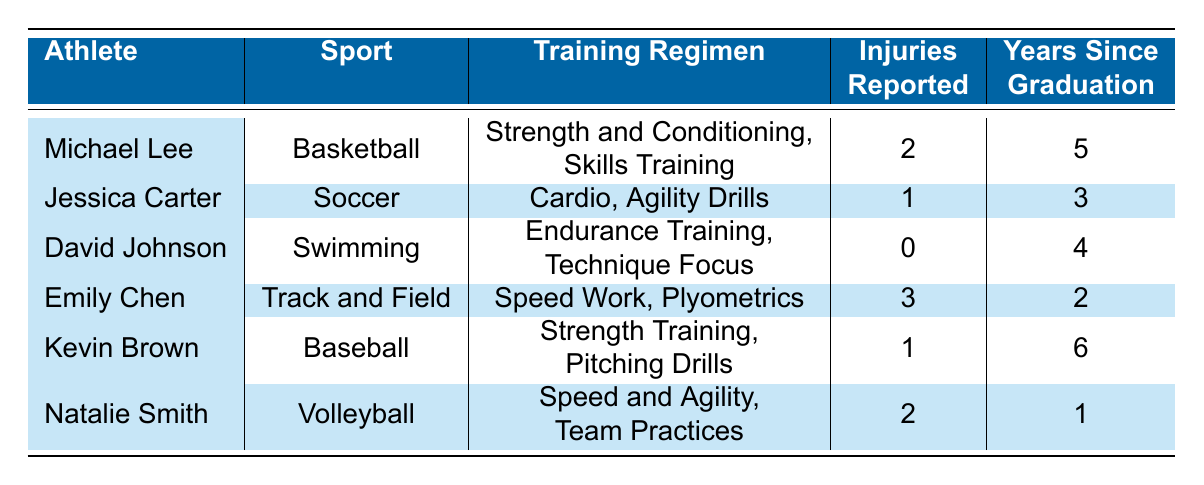What is the training regimen of Emily Chen? The table lists Emily Chen under the athlete name, and her training regimen is described as "Speed Work, Plyometrics."
Answer: Speed Work, Plyometrics How many injuries has David Johnson reported? Referring to the row for David Johnson, it shows that he has reported 0 injuries.
Answer: 0 Which athlete has the most reported injuries? By scanning the injuries reported column, Emily Chen has 3 reported injuries, which is the highest number among all athletes listed.
Answer: Emily Chen What is the average number of injuries reported by all athletes? To find the average, sum the reported injuries (2 + 1 + 0 + 3 + 1 + 2 = 9) and divide by the total number of athletes (6). Therefore, the average is 9 / 6 = 1.5.
Answer: 1.5 Is it true that Kevin Brown has an injury report of 1? Checking Kevin Brown's entry in the table, it states that he has reported 1 injury, confirming the statement as correct.
Answer: Yes Are there any athletes who reported more than 2 injuries? By examining the injuries reported column, only Emily Chen has reported more than 2 injuries (she reported 3), so the answer is based on this evaluation.
Answer: Yes How many athletes are there with a training regimen that includes strength training? By scanning the training regimen column, Michael Lee and Kevin Brown both have a training regimen that includes some form of strength training. Therefore, there are 2 athletes.
Answer: 2 What is the total number of years since graduation for all athletes combined? Adding the years since graduation from each athlete (5 + 3 + 4 + 2 + 6 + 1 = 21) gives a total of 21 years combined since graduation.
Answer: 21 What sport does Jessica Carter play? From the table, Jessica Carter's entry specifies she plays Soccer.
Answer: Soccer 